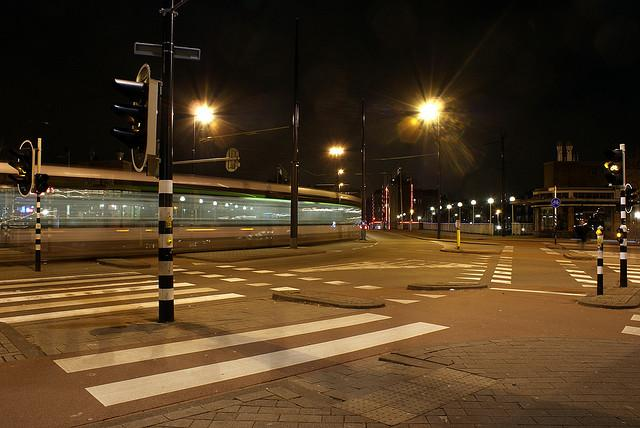What time of day is shown here? Please explain your reasoning. late night. The sky is dark. 